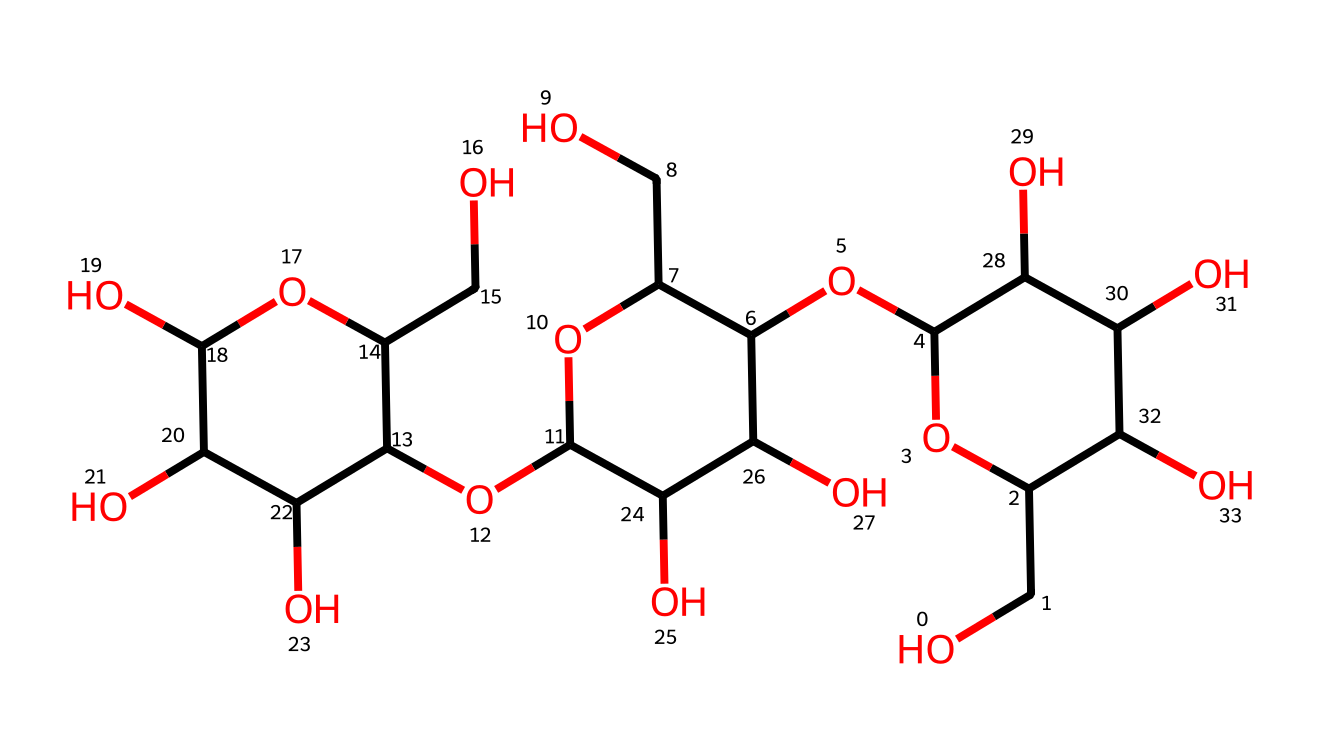What is the main structural component of this chemical? The chemical consists primarily of glucose units that are linked together, characteristic of cellulose.
Answer: cellulose How many carbohydrate rings are present in this chemical? By analyzing the structure, there are multiple rings; specifically, there are three interconnected rings that correspond to the multiple glucose units.
Answer: three What type of linkage connects the glucose units in this chemical? The linkage is a glycosidic bond, which connects the hydroxyl groups of one glucose molecule to another, giving cellulose its structural properties.
Answer: glycosidic bond How many hydroxyl groups are attached to the glucose units in this structure? Each glucose unit contributes multiple hydroxyl (–OH) groups, and counting them shows that there are a total of eight hydroxyl groups throughout the structure.
Answer: eight What is the potential physical characteristic of cellulose fibers due to their structure? The extensive hydrogen bonding between hydroxyl groups leads to the characteristic strength and rigidity of cellulose fibers.
Answer: strong 